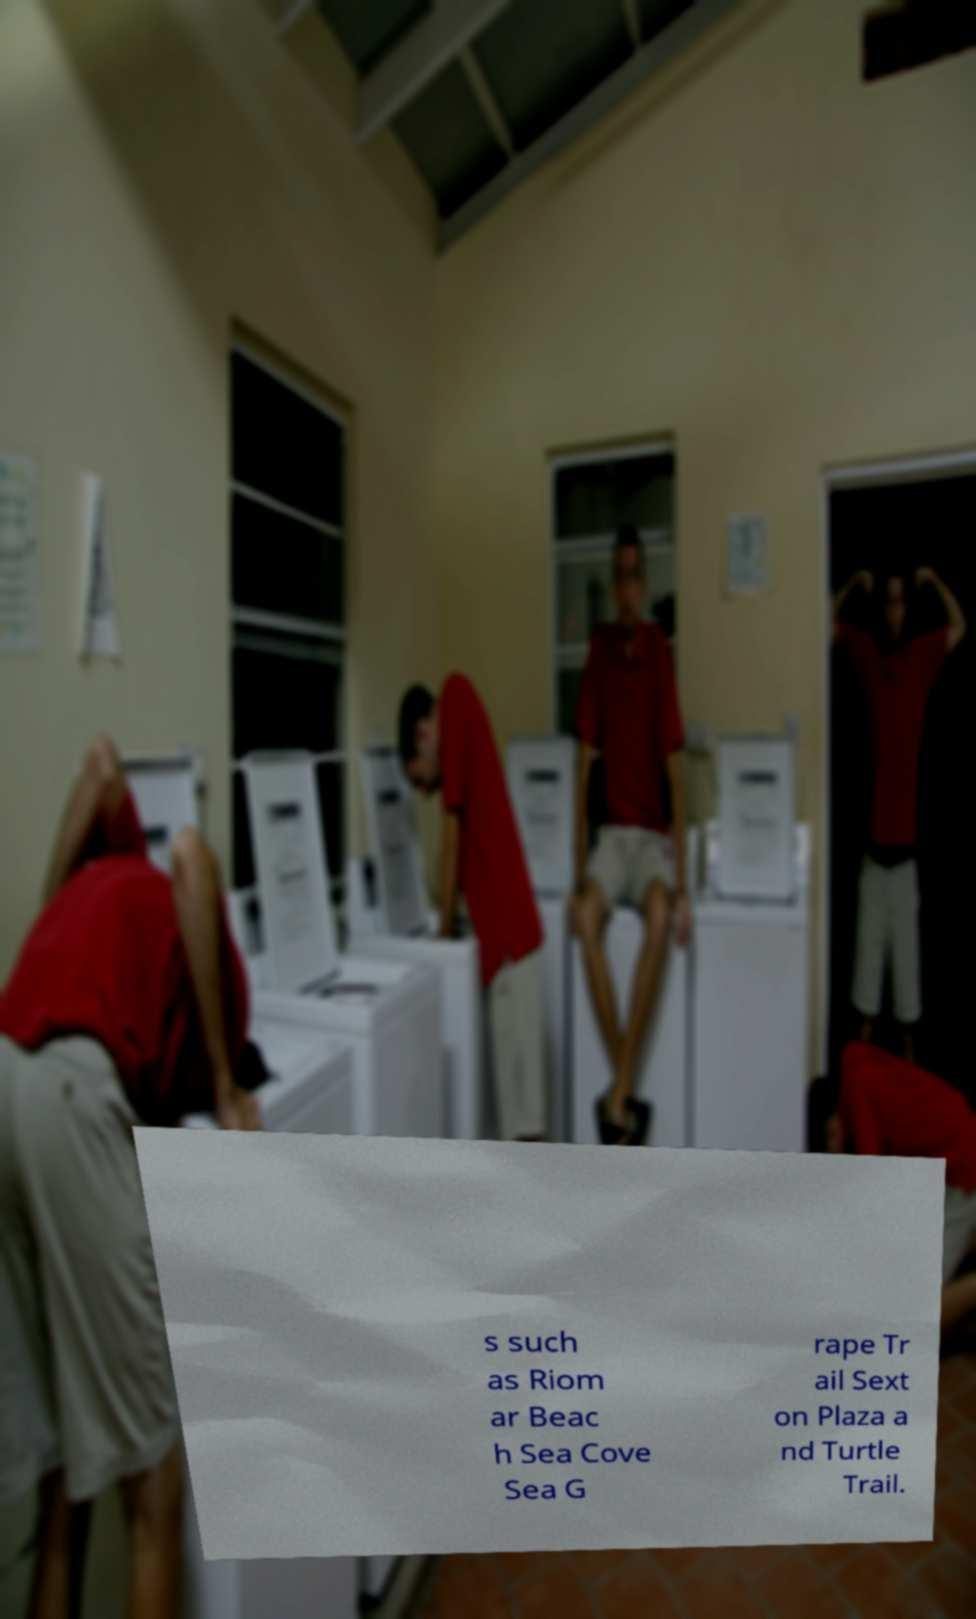Could you extract and type out the text from this image? s such as Riom ar Beac h Sea Cove Sea G rape Tr ail Sext on Plaza a nd Turtle Trail. 